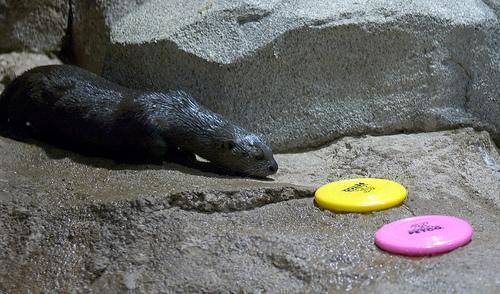How many toys are there?
Give a very brief answer. 2. 